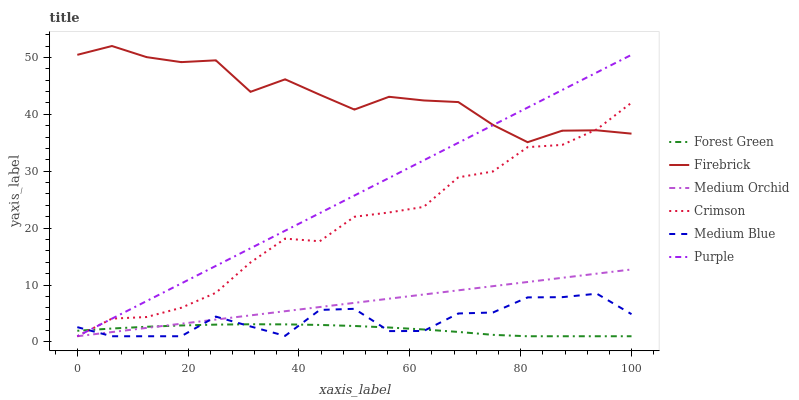Does Forest Green have the minimum area under the curve?
Answer yes or no. Yes. Does Firebrick have the maximum area under the curve?
Answer yes or no. Yes. Does Medium Orchid have the minimum area under the curve?
Answer yes or no. No. Does Medium Orchid have the maximum area under the curve?
Answer yes or no. No. Is Medium Orchid the smoothest?
Answer yes or no. Yes. Is Firebrick the roughest?
Answer yes or no. Yes. Is Firebrick the smoothest?
Answer yes or no. No. Is Medium Orchid the roughest?
Answer yes or no. No. Does Purple have the lowest value?
Answer yes or no. Yes. Does Firebrick have the lowest value?
Answer yes or no. No. Does Firebrick have the highest value?
Answer yes or no. Yes. Does Medium Orchid have the highest value?
Answer yes or no. No. Is Forest Green less than Firebrick?
Answer yes or no. Yes. Is Firebrick greater than Medium Orchid?
Answer yes or no. Yes. Does Purple intersect Medium Blue?
Answer yes or no. Yes. Is Purple less than Medium Blue?
Answer yes or no. No. Is Purple greater than Medium Blue?
Answer yes or no. No. Does Forest Green intersect Firebrick?
Answer yes or no. No. 